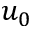Convert formula to latex. <formula><loc_0><loc_0><loc_500><loc_500>u _ { 0 }</formula> 